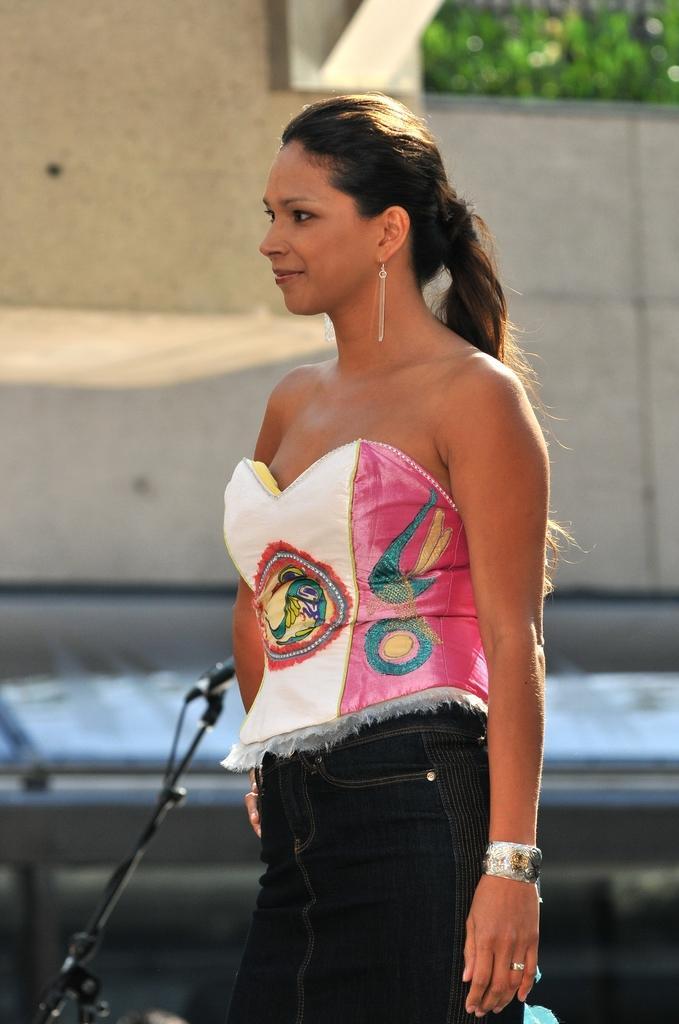Can you describe this image briefly? In this image we can see a lady, there is a mic, and stand, also we can see the wall, plants. 